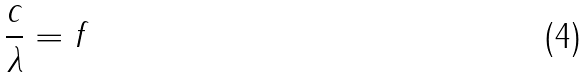Convert formula to latex. <formula><loc_0><loc_0><loc_500><loc_500>\frac { c } { \lambda } = f</formula> 